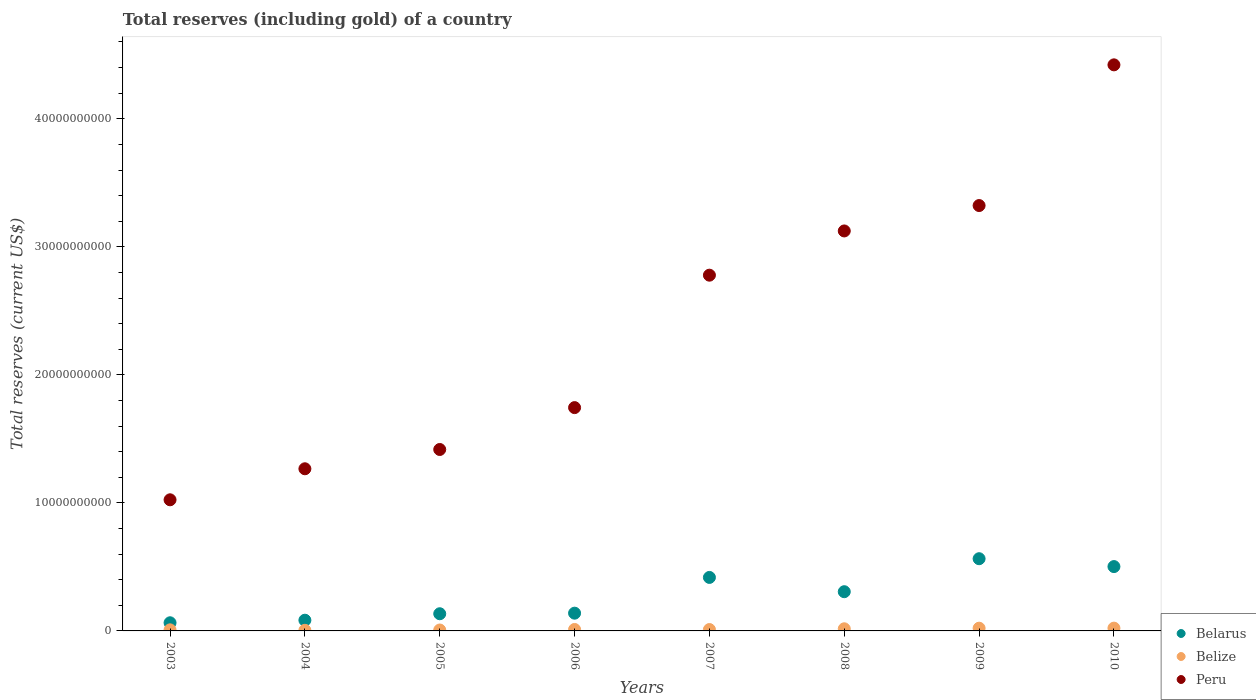Is the number of dotlines equal to the number of legend labels?
Make the answer very short. Yes. What is the total reserves (including gold) in Belarus in 2009?
Keep it short and to the point. 5.64e+09. Across all years, what is the maximum total reserves (including gold) in Belarus?
Give a very brief answer. 5.64e+09. Across all years, what is the minimum total reserves (including gold) in Belize?
Your answer should be very brief. 4.83e+07. In which year was the total reserves (including gold) in Belarus maximum?
Provide a succinct answer. 2009. What is the total total reserves (including gold) in Peru in the graph?
Offer a very short reply. 1.91e+11. What is the difference between the total reserves (including gold) in Peru in 2007 and that in 2009?
Your answer should be very brief. -5.44e+09. What is the difference between the total reserves (including gold) in Belarus in 2004 and the total reserves (including gold) in Peru in 2009?
Your answer should be compact. -3.24e+1. What is the average total reserves (including gold) in Belize per year?
Ensure brevity in your answer.  1.28e+08. In the year 2010, what is the difference between the total reserves (including gold) in Belize and total reserves (including gold) in Belarus?
Provide a short and direct response. -4.81e+09. In how many years, is the total reserves (including gold) in Peru greater than 8000000000 US$?
Your answer should be very brief. 8. What is the ratio of the total reserves (including gold) in Belarus in 2008 to that in 2009?
Your answer should be compact. 0.54. Is the difference between the total reserves (including gold) in Belize in 2005 and 2010 greater than the difference between the total reserves (including gold) in Belarus in 2005 and 2010?
Offer a terse response. Yes. What is the difference between the highest and the second highest total reserves (including gold) in Belarus?
Your answer should be compact. 6.15e+08. What is the difference between the highest and the lowest total reserves (including gold) in Belarus?
Provide a succinct answer. 5.00e+09. In how many years, is the total reserves (including gold) in Peru greater than the average total reserves (including gold) in Peru taken over all years?
Make the answer very short. 4. Is the total reserves (including gold) in Peru strictly greater than the total reserves (including gold) in Belarus over the years?
Offer a terse response. Yes. Is the total reserves (including gold) in Belize strictly less than the total reserves (including gold) in Peru over the years?
Your response must be concise. Yes. How many dotlines are there?
Give a very brief answer. 3. What is the difference between two consecutive major ticks on the Y-axis?
Offer a very short reply. 1.00e+1. Are the values on the major ticks of Y-axis written in scientific E-notation?
Provide a succinct answer. No. Does the graph contain grids?
Offer a very short reply. No. How many legend labels are there?
Provide a short and direct response. 3. What is the title of the graph?
Offer a terse response. Total reserves (including gold) of a country. Does "United States" appear as one of the legend labels in the graph?
Offer a terse response. No. What is the label or title of the Y-axis?
Your answer should be very brief. Total reserves (current US$). What is the Total reserves (current US$) of Belarus in 2003?
Ensure brevity in your answer.  6.37e+08. What is the Total reserves (current US$) of Belize in 2003?
Your answer should be very brief. 8.47e+07. What is the Total reserves (current US$) of Peru in 2003?
Your answer should be very brief. 1.02e+1. What is the Total reserves (current US$) of Belarus in 2004?
Your response must be concise. 8.37e+08. What is the Total reserves (current US$) in Belize in 2004?
Your answer should be compact. 4.83e+07. What is the Total reserves (current US$) in Peru in 2004?
Your answer should be compact. 1.27e+1. What is the Total reserves (current US$) in Belarus in 2005?
Your answer should be compact. 1.34e+09. What is the Total reserves (current US$) in Belize in 2005?
Provide a short and direct response. 7.14e+07. What is the Total reserves (current US$) of Peru in 2005?
Provide a short and direct response. 1.42e+1. What is the Total reserves (current US$) in Belarus in 2006?
Your response must be concise. 1.39e+09. What is the Total reserves (current US$) in Belize in 2006?
Offer a terse response. 1.14e+08. What is the Total reserves (current US$) in Peru in 2006?
Provide a succinct answer. 1.74e+1. What is the Total reserves (current US$) of Belarus in 2007?
Your answer should be very brief. 4.18e+09. What is the Total reserves (current US$) in Belize in 2007?
Provide a short and direct response. 1.09e+08. What is the Total reserves (current US$) in Peru in 2007?
Your answer should be very brief. 2.78e+1. What is the Total reserves (current US$) in Belarus in 2008?
Give a very brief answer. 3.06e+09. What is the Total reserves (current US$) in Belize in 2008?
Your answer should be compact. 1.66e+08. What is the Total reserves (current US$) of Peru in 2008?
Keep it short and to the point. 3.12e+1. What is the Total reserves (current US$) of Belarus in 2009?
Your response must be concise. 5.64e+09. What is the Total reserves (current US$) of Belize in 2009?
Offer a very short reply. 2.14e+08. What is the Total reserves (current US$) of Peru in 2009?
Offer a very short reply. 3.32e+1. What is the Total reserves (current US$) of Belarus in 2010?
Ensure brevity in your answer.  5.03e+09. What is the Total reserves (current US$) of Belize in 2010?
Give a very brief answer. 2.18e+08. What is the Total reserves (current US$) of Peru in 2010?
Your response must be concise. 4.42e+1. Across all years, what is the maximum Total reserves (current US$) of Belarus?
Offer a very short reply. 5.64e+09. Across all years, what is the maximum Total reserves (current US$) of Belize?
Your answer should be very brief. 2.18e+08. Across all years, what is the maximum Total reserves (current US$) of Peru?
Keep it short and to the point. 4.42e+1. Across all years, what is the minimum Total reserves (current US$) in Belarus?
Keep it short and to the point. 6.37e+08. Across all years, what is the minimum Total reserves (current US$) of Belize?
Provide a succinct answer. 4.83e+07. Across all years, what is the minimum Total reserves (current US$) of Peru?
Provide a short and direct response. 1.02e+1. What is the total Total reserves (current US$) in Belarus in the graph?
Your answer should be very brief. 2.21e+1. What is the total Total reserves (current US$) of Belize in the graph?
Your answer should be very brief. 1.02e+09. What is the total Total reserves (current US$) of Peru in the graph?
Provide a succinct answer. 1.91e+11. What is the difference between the Total reserves (current US$) in Belarus in 2003 and that in 2004?
Give a very brief answer. -2.00e+08. What is the difference between the Total reserves (current US$) of Belize in 2003 and that in 2004?
Your answer should be compact. 3.64e+07. What is the difference between the Total reserves (current US$) of Peru in 2003 and that in 2004?
Keep it short and to the point. -2.42e+09. What is the difference between the Total reserves (current US$) in Belarus in 2003 and that in 2005?
Keep it short and to the point. -7.05e+08. What is the difference between the Total reserves (current US$) in Belize in 2003 and that in 2005?
Offer a very short reply. 1.33e+07. What is the difference between the Total reserves (current US$) in Peru in 2003 and that in 2005?
Your response must be concise. -3.93e+09. What is the difference between the Total reserves (current US$) in Belarus in 2003 and that in 2006?
Offer a terse response. -7.50e+08. What is the difference between the Total reserves (current US$) in Belize in 2003 and that in 2006?
Offer a terse response. -2.90e+07. What is the difference between the Total reserves (current US$) of Peru in 2003 and that in 2006?
Your answer should be compact. -7.20e+09. What is the difference between the Total reserves (current US$) in Belarus in 2003 and that in 2007?
Provide a succinct answer. -3.54e+09. What is the difference between the Total reserves (current US$) of Belize in 2003 and that in 2007?
Your answer should be compact. -2.38e+07. What is the difference between the Total reserves (current US$) in Peru in 2003 and that in 2007?
Provide a succinct answer. -1.75e+1. What is the difference between the Total reserves (current US$) of Belarus in 2003 and that in 2008?
Your response must be concise. -2.43e+09. What is the difference between the Total reserves (current US$) of Belize in 2003 and that in 2008?
Give a very brief answer. -8.15e+07. What is the difference between the Total reserves (current US$) in Peru in 2003 and that in 2008?
Provide a short and direct response. -2.10e+1. What is the difference between the Total reserves (current US$) of Belarus in 2003 and that in 2009?
Provide a succinct answer. -5.00e+09. What is the difference between the Total reserves (current US$) of Belize in 2003 and that in 2009?
Your answer should be compact. -1.29e+08. What is the difference between the Total reserves (current US$) in Peru in 2003 and that in 2009?
Your response must be concise. -2.30e+1. What is the difference between the Total reserves (current US$) in Belarus in 2003 and that in 2010?
Offer a terse response. -4.39e+09. What is the difference between the Total reserves (current US$) in Belize in 2003 and that in 2010?
Make the answer very short. -1.33e+08. What is the difference between the Total reserves (current US$) of Peru in 2003 and that in 2010?
Provide a succinct answer. -3.40e+1. What is the difference between the Total reserves (current US$) of Belarus in 2004 and that in 2005?
Offer a terse response. -5.05e+08. What is the difference between the Total reserves (current US$) in Belize in 2004 and that in 2005?
Keep it short and to the point. -2.31e+07. What is the difference between the Total reserves (current US$) in Peru in 2004 and that in 2005?
Give a very brief answer. -1.51e+09. What is the difference between the Total reserves (current US$) of Belarus in 2004 and that in 2006?
Provide a succinct answer. -5.49e+08. What is the difference between the Total reserves (current US$) in Belize in 2004 and that in 2006?
Your response must be concise. -6.55e+07. What is the difference between the Total reserves (current US$) of Peru in 2004 and that in 2006?
Your response must be concise. -4.78e+09. What is the difference between the Total reserves (current US$) of Belarus in 2004 and that in 2007?
Ensure brevity in your answer.  -3.34e+09. What is the difference between the Total reserves (current US$) of Belize in 2004 and that in 2007?
Provide a short and direct response. -6.03e+07. What is the difference between the Total reserves (current US$) in Peru in 2004 and that in 2007?
Your answer should be compact. -1.51e+1. What is the difference between the Total reserves (current US$) in Belarus in 2004 and that in 2008?
Offer a very short reply. -2.23e+09. What is the difference between the Total reserves (current US$) of Belize in 2004 and that in 2008?
Provide a succinct answer. -1.18e+08. What is the difference between the Total reserves (current US$) of Peru in 2004 and that in 2008?
Your response must be concise. -1.86e+1. What is the difference between the Total reserves (current US$) of Belarus in 2004 and that in 2009?
Provide a short and direct response. -4.80e+09. What is the difference between the Total reserves (current US$) in Belize in 2004 and that in 2009?
Provide a succinct answer. -1.65e+08. What is the difference between the Total reserves (current US$) of Peru in 2004 and that in 2009?
Provide a short and direct response. -2.06e+1. What is the difference between the Total reserves (current US$) in Belarus in 2004 and that in 2010?
Offer a very short reply. -4.19e+09. What is the difference between the Total reserves (current US$) in Belize in 2004 and that in 2010?
Ensure brevity in your answer.  -1.70e+08. What is the difference between the Total reserves (current US$) of Peru in 2004 and that in 2010?
Make the answer very short. -3.16e+1. What is the difference between the Total reserves (current US$) in Belarus in 2005 and that in 2006?
Keep it short and to the point. -4.46e+07. What is the difference between the Total reserves (current US$) of Belize in 2005 and that in 2006?
Your answer should be compact. -4.24e+07. What is the difference between the Total reserves (current US$) in Peru in 2005 and that in 2006?
Keep it short and to the point. -3.27e+09. What is the difference between the Total reserves (current US$) in Belarus in 2005 and that in 2007?
Your answer should be very brief. -2.84e+09. What is the difference between the Total reserves (current US$) of Belize in 2005 and that in 2007?
Your answer should be compact. -3.72e+07. What is the difference between the Total reserves (current US$) in Peru in 2005 and that in 2007?
Provide a succinct answer. -1.36e+1. What is the difference between the Total reserves (current US$) of Belarus in 2005 and that in 2008?
Give a very brief answer. -1.72e+09. What is the difference between the Total reserves (current US$) of Belize in 2005 and that in 2008?
Your answer should be very brief. -9.48e+07. What is the difference between the Total reserves (current US$) in Peru in 2005 and that in 2008?
Ensure brevity in your answer.  -1.71e+1. What is the difference between the Total reserves (current US$) in Belarus in 2005 and that in 2009?
Provide a succinct answer. -4.30e+09. What is the difference between the Total reserves (current US$) in Belize in 2005 and that in 2009?
Make the answer very short. -1.42e+08. What is the difference between the Total reserves (current US$) in Peru in 2005 and that in 2009?
Ensure brevity in your answer.  -1.91e+1. What is the difference between the Total reserves (current US$) in Belarus in 2005 and that in 2010?
Provide a short and direct response. -3.68e+09. What is the difference between the Total reserves (current US$) in Belize in 2005 and that in 2010?
Your answer should be compact. -1.47e+08. What is the difference between the Total reserves (current US$) of Peru in 2005 and that in 2010?
Your response must be concise. -3.00e+1. What is the difference between the Total reserves (current US$) of Belarus in 2006 and that in 2007?
Make the answer very short. -2.79e+09. What is the difference between the Total reserves (current US$) of Belize in 2006 and that in 2007?
Ensure brevity in your answer.  5.21e+06. What is the difference between the Total reserves (current US$) in Peru in 2006 and that in 2007?
Give a very brief answer. -1.03e+1. What is the difference between the Total reserves (current US$) in Belarus in 2006 and that in 2008?
Offer a terse response. -1.68e+09. What is the difference between the Total reserves (current US$) of Belize in 2006 and that in 2008?
Ensure brevity in your answer.  -5.24e+07. What is the difference between the Total reserves (current US$) of Peru in 2006 and that in 2008?
Keep it short and to the point. -1.38e+1. What is the difference between the Total reserves (current US$) in Belarus in 2006 and that in 2009?
Provide a short and direct response. -4.25e+09. What is the difference between the Total reserves (current US$) in Belize in 2006 and that in 2009?
Ensure brevity in your answer.  -1.00e+08. What is the difference between the Total reserves (current US$) of Peru in 2006 and that in 2009?
Provide a succinct answer. -1.58e+1. What is the difference between the Total reserves (current US$) in Belarus in 2006 and that in 2010?
Your answer should be compact. -3.64e+09. What is the difference between the Total reserves (current US$) in Belize in 2006 and that in 2010?
Ensure brevity in your answer.  -1.04e+08. What is the difference between the Total reserves (current US$) in Peru in 2006 and that in 2010?
Provide a short and direct response. -2.68e+1. What is the difference between the Total reserves (current US$) in Belarus in 2007 and that in 2008?
Offer a very short reply. 1.12e+09. What is the difference between the Total reserves (current US$) of Belize in 2007 and that in 2008?
Your response must be concise. -5.77e+07. What is the difference between the Total reserves (current US$) of Peru in 2007 and that in 2008?
Your answer should be compact. -3.46e+09. What is the difference between the Total reserves (current US$) in Belarus in 2007 and that in 2009?
Give a very brief answer. -1.46e+09. What is the difference between the Total reserves (current US$) of Belize in 2007 and that in 2009?
Give a very brief answer. -1.05e+08. What is the difference between the Total reserves (current US$) of Peru in 2007 and that in 2009?
Provide a succinct answer. -5.44e+09. What is the difference between the Total reserves (current US$) in Belarus in 2007 and that in 2010?
Make the answer very short. -8.47e+08. What is the difference between the Total reserves (current US$) of Belize in 2007 and that in 2010?
Ensure brevity in your answer.  -1.09e+08. What is the difference between the Total reserves (current US$) in Peru in 2007 and that in 2010?
Provide a short and direct response. -1.64e+1. What is the difference between the Total reserves (current US$) in Belarus in 2008 and that in 2009?
Give a very brief answer. -2.58e+09. What is the difference between the Total reserves (current US$) of Belize in 2008 and that in 2009?
Give a very brief answer. -4.75e+07. What is the difference between the Total reserves (current US$) of Peru in 2008 and that in 2009?
Give a very brief answer. -1.98e+09. What is the difference between the Total reserves (current US$) in Belarus in 2008 and that in 2010?
Offer a terse response. -1.96e+09. What is the difference between the Total reserves (current US$) in Belize in 2008 and that in 2010?
Ensure brevity in your answer.  -5.18e+07. What is the difference between the Total reserves (current US$) of Peru in 2008 and that in 2010?
Give a very brief answer. -1.30e+1. What is the difference between the Total reserves (current US$) in Belarus in 2009 and that in 2010?
Your answer should be very brief. 6.15e+08. What is the difference between the Total reserves (current US$) of Belize in 2009 and that in 2010?
Offer a very short reply. -4.32e+06. What is the difference between the Total reserves (current US$) of Peru in 2009 and that in 2010?
Offer a very short reply. -1.10e+1. What is the difference between the Total reserves (current US$) of Belarus in 2003 and the Total reserves (current US$) of Belize in 2004?
Provide a succinct answer. 5.88e+08. What is the difference between the Total reserves (current US$) of Belarus in 2003 and the Total reserves (current US$) of Peru in 2004?
Provide a succinct answer. -1.20e+1. What is the difference between the Total reserves (current US$) of Belize in 2003 and the Total reserves (current US$) of Peru in 2004?
Give a very brief answer. -1.26e+1. What is the difference between the Total reserves (current US$) in Belarus in 2003 and the Total reserves (current US$) in Belize in 2005?
Keep it short and to the point. 5.65e+08. What is the difference between the Total reserves (current US$) in Belarus in 2003 and the Total reserves (current US$) in Peru in 2005?
Your answer should be compact. -1.35e+1. What is the difference between the Total reserves (current US$) in Belize in 2003 and the Total reserves (current US$) in Peru in 2005?
Provide a succinct answer. -1.41e+1. What is the difference between the Total reserves (current US$) in Belarus in 2003 and the Total reserves (current US$) in Belize in 2006?
Make the answer very short. 5.23e+08. What is the difference between the Total reserves (current US$) of Belarus in 2003 and the Total reserves (current US$) of Peru in 2006?
Ensure brevity in your answer.  -1.68e+1. What is the difference between the Total reserves (current US$) in Belize in 2003 and the Total reserves (current US$) in Peru in 2006?
Your answer should be very brief. -1.74e+1. What is the difference between the Total reserves (current US$) of Belarus in 2003 and the Total reserves (current US$) of Belize in 2007?
Make the answer very short. 5.28e+08. What is the difference between the Total reserves (current US$) of Belarus in 2003 and the Total reserves (current US$) of Peru in 2007?
Your answer should be compact. -2.71e+1. What is the difference between the Total reserves (current US$) in Belize in 2003 and the Total reserves (current US$) in Peru in 2007?
Provide a short and direct response. -2.77e+1. What is the difference between the Total reserves (current US$) of Belarus in 2003 and the Total reserves (current US$) of Belize in 2008?
Your answer should be very brief. 4.70e+08. What is the difference between the Total reserves (current US$) in Belarus in 2003 and the Total reserves (current US$) in Peru in 2008?
Ensure brevity in your answer.  -3.06e+1. What is the difference between the Total reserves (current US$) of Belize in 2003 and the Total reserves (current US$) of Peru in 2008?
Your answer should be very brief. -3.12e+1. What is the difference between the Total reserves (current US$) in Belarus in 2003 and the Total reserves (current US$) in Belize in 2009?
Ensure brevity in your answer.  4.23e+08. What is the difference between the Total reserves (current US$) in Belarus in 2003 and the Total reserves (current US$) in Peru in 2009?
Keep it short and to the point. -3.26e+1. What is the difference between the Total reserves (current US$) of Belize in 2003 and the Total reserves (current US$) of Peru in 2009?
Provide a succinct answer. -3.31e+1. What is the difference between the Total reserves (current US$) in Belarus in 2003 and the Total reserves (current US$) in Belize in 2010?
Provide a succinct answer. 4.19e+08. What is the difference between the Total reserves (current US$) of Belarus in 2003 and the Total reserves (current US$) of Peru in 2010?
Your answer should be very brief. -4.36e+1. What is the difference between the Total reserves (current US$) in Belize in 2003 and the Total reserves (current US$) in Peru in 2010?
Give a very brief answer. -4.41e+1. What is the difference between the Total reserves (current US$) of Belarus in 2004 and the Total reserves (current US$) of Belize in 2005?
Provide a short and direct response. 7.66e+08. What is the difference between the Total reserves (current US$) of Belarus in 2004 and the Total reserves (current US$) of Peru in 2005?
Your response must be concise. -1.33e+1. What is the difference between the Total reserves (current US$) of Belize in 2004 and the Total reserves (current US$) of Peru in 2005?
Keep it short and to the point. -1.41e+1. What is the difference between the Total reserves (current US$) of Belarus in 2004 and the Total reserves (current US$) of Belize in 2006?
Offer a very short reply. 7.23e+08. What is the difference between the Total reserves (current US$) in Belarus in 2004 and the Total reserves (current US$) in Peru in 2006?
Ensure brevity in your answer.  -1.66e+1. What is the difference between the Total reserves (current US$) of Belize in 2004 and the Total reserves (current US$) of Peru in 2006?
Offer a terse response. -1.74e+1. What is the difference between the Total reserves (current US$) in Belarus in 2004 and the Total reserves (current US$) in Belize in 2007?
Offer a terse response. 7.28e+08. What is the difference between the Total reserves (current US$) of Belarus in 2004 and the Total reserves (current US$) of Peru in 2007?
Give a very brief answer. -2.69e+1. What is the difference between the Total reserves (current US$) in Belize in 2004 and the Total reserves (current US$) in Peru in 2007?
Make the answer very short. -2.77e+1. What is the difference between the Total reserves (current US$) in Belarus in 2004 and the Total reserves (current US$) in Belize in 2008?
Offer a very short reply. 6.71e+08. What is the difference between the Total reserves (current US$) of Belarus in 2004 and the Total reserves (current US$) of Peru in 2008?
Make the answer very short. -3.04e+1. What is the difference between the Total reserves (current US$) in Belize in 2004 and the Total reserves (current US$) in Peru in 2008?
Offer a terse response. -3.12e+1. What is the difference between the Total reserves (current US$) of Belarus in 2004 and the Total reserves (current US$) of Belize in 2009?
Your answer should be compact. 6.23e+08. What is the difference between the Total reserves (current US$) of Belarus in 2004 and the Total reserves (current US$) of Peru in 2009?
Provide a succinct answer. -3.24e+1. What is the difference between the Total reserves (current US$) in Belize in 2004 and the Total reserves (current US$) in Peru in 2009?
Give a very brief answer. -3.32e+1. What is the difference between the Total reserves (current US$) of Belarus in 2004 and the Total reserves (current US$) of Belize in 2010?
Ensure brevity in your answer.  6.19e+08. What is the difference between the Total reserves (current US$) in Belarus in 2004 and the Total reserves (current US$) in Peru in 2010?
Offer a terse response. -4.34e+1. What is the difference between the Total reserves (current US$) in Belize in 2004 and the Total reserves (current US$) in Peru in 2010?
Provide a short and direct response. -4.42e+1. What is the difference between the Total reserves (current US$) of Belarus in 2005 and the Total reserves (current US$) of Belize in 2006?
Your response must be concise. 1.23e+09. What is the difference between the Total reserves (current US$) of Belarus in 2005 and the Total reserves (current US$) of Peru in 2006?
Provide a short and direct response. -1.61e+1. What is the difference between the Total reserves (current US$) in Belize in 2005 and the Total reserves (current US$) in Peru in 2006?
Your answer should be compact. -1.74e+1. What is the difference between the Total reserves (current US$) in Belarus in 2005 and the Total reserves (current US$) in Belize in 2007?
Your answer should be very brief. 1.23e+09. What is the difference between the Total reserves (current US$) of Belarus in 2005 and the Total reserves (current US$) of Peru in 2007?
Keep it short and to the point. -2.64e+1. What is the difference between the Total reserves (current US$) of Belize in 2005 and the Total reserves (current US$) of Peru in 2007?
Offer a terse response. -2.77e+1. What is the difference between the Total reserves (current US$) of Belarus in 2005 and the Total reserves (current US$) of Belize in 2008?
Ensure brevity in your answer.  1.18e+09. What is the difference between the Total reserves (current US$) of Belarus in 2005 and the Total reserves (current US$) of Peru in 2008?
Offer a very short reply. -2.99e+1. What is the difference between the Total reserves (current US$) in Belize in 2005 and the Total reserves (current US$) in Peru in 2008?
Make the answer very short. -3.12e+1. What is the difference between the Total reserves (current US$) of Belarus in 2005 and the Total reserves (current US$) of Belize in 2009?
Provide a short and direct response. 1.13e+09. What is the difference between the Total reserves (current US$) in Belarus in 2005 and the Total reserves (current US$) in Peru in 2009?
Your answer should be very brief. -3.19e+1. What is the difference between the Total reserves (current US$) of Belize in 2005 and the Total reserves (current US$) of Peru in 2009?
Your answer should be compact. -3.32e+1. What is the difference between the Total reserves (current US$) in Belarus in 2005 and the Total reserves (current US$) in Belize in 2010?
Your answer should be very brief. 1.12e+09. What is the difference between the Total reserves (current US$) in Belarus in 2005 and the Total reserves (current US$) in Peru in 2010?
Provide a short and direct response. -4.29e+1. What is the difference between the Total reserves (current US$) in Belize in 2005 and the Total reserves (current US$) in Peru in 2010?
Offer a very short reply. -4.41e+1. What is the difference between the Total reserves (current US$) in Belarus in 2006 and the Total reserves (current US$) in Belize in 2007?
Your response must be concise. 1.28e+09. What is the difference between the Total reserves (current US$) in Belarus in 2006 and the Total reserves (current US$) in Peru in 2007?
Your answer should be very brief. -2.64e+1. What is the difference between the Total reserves (current US$) in Belize in 2006 and the Total reserves (current US$) in Peru in 2007?
Offer a very short reply. -2.77e+1. What is the difference between the Total reserves (current US$) of Belarus in 2006 and the Total reserves (current US$) of Belize in 2008?
Your answer should be compact. 1.22e+09. What is the difference between the Total reserves (current US$) of Belarus in 2006 and the Total reserves (current US$) of Peru in 2008?
Offer a terse response. -2.99e+1. What is the difference between the Total reserves (current US$) of Belize in 2006 and the Total reserves (current US$) of Peru in 2008?
Provide a succinct answer. -3.11e+1. What is the difference between the Total reserves (current US$) in Belarus in 2006 and the Total reserves (current US$) in Belize in 2009?
Give a very brief answer. 1.17e+09. What is the difference between the Total reserves (current US$) in Belarus in 2006 and the Total reserves (current US$) in Peru in 2009?
Offer a terse response. -3.18e+1. What is the difference between the Total reserves (current US$) of Belize in 2006 and the Total reserves (current US$) of Peru in 2009?
Ensure brevity in your answer.  -3.31e+1. What is the difference between the Total reserves (current US$) of Belarus in 2006 and the Total reserves (current US$) of Belize in 2010?
Give a very brief answer. 1.17e+09. What is the difference between the Total reserves (current US$) in Belarus in 2006 and the Total reserves (current US$) in Peru in 2010?
Ensure brevity in your answer.  -4.28e+1. What is the difference between the Total reserves (current US$) of Belize in 2006 and the Total reserves (current US$) of Peru in 2010?
Give a very brief answer. -4.41e+1. What is the difference between the Total reserves (current US$) of Belarus in 2007 and the Total reserves (current US$) of Belize in 2008?
Make the answer very short. 4.01e+09. What is the difference between the Total reserves (current US$) of Belarus in 2007 and the Total reserves (current US$) of Peru in 2008?
Provide a succinct answer. -2.71e+1. What is the difference between the Total reserves (current US$) in Belize in 2007 and the Total reserves (current US$) in Peru in 2008?
Your response must be concise. -3.11e+1. What is the difference between the Total reserves (current US$) in Belarus in 2007 and the Total reserves (current US$) in Belize in 2009?
Provide a short and direct response. 3.96e+09. What is the difference between the Total reserves (current US$) of Belarus in 2007 and the Total reserves (current US$) of Peru in 2009?
Offer a terse response. -2.90e+1. What is the difference between the Total reserves (current US$) of Belize in 2007 and the Total reserves (current US$) of Peru in 2009?
Make the answer very short. -3.31e+1. What is the difference between the Total reserves (current US$) of Belarus in 2007 and the Total reserves (current US$) of Belize in 2010?
Provide a succinct answer. 3.96e+09. What is the difference between the Total reserves (current US$) of Belarus in 2007 and the Total reserves (current US$) of Peru in 2010?
Provide a short and direct response. -4.00e+1. What is the difference between the Total reserves (current US$) of Belize in 2007 and the Total reserves (current US$) of Peru in 2010?
Offer a terse response. -4.41e+1. What is the difference between the Total reserves (current US$) of Belarus in 2008 and the Total reserves (current US$) of Belize in 2009?
Your response must be concise. 2.85e+09. What is the difference between the Total reserves (current US$) of Belarus in 2008 and the Total reserves (current US$) of Peru in 2009?
Ensure brevity in your answer.  -3.02e+1. What is the difference between the Total reserves (current US$) of Belize in 2008 and the Total reserves (current US$) of Peru in 2009?
Your answer should be compact. -3.31e+1. What is the difference between the Total reserves (current US$) in Belarus in 2008 and the Total reserves (current US$) in Belize in 2010?
Your response must be concise. 2.85e+09. What is the difference between the Total reserves (current US$) in Belarus in 2008 and the Total reserves (current US$) in Peru in 2010?
Make the answer very short. -4.12e+1. What is the difference between the Total reserves (current US$) in Belize in 2008 and the Total reserves (current US$) in Peru in 2010?
Your answer should be compact. -4.40e+1. What is the difference between the Total reserves (current US$) in Belarus in 2009 and the Total reserves (current US$) in Belize in 2010?
Your response must be concise. 5.42e+09. What is the difference between the Total reserves (current US$) of Belarus in 2009 and the Total reserves (current US$) of Peru in 2010?
Offer a very short reply. -3.86e+1. What is the difference between the Total reserves (current US$) of Belize in 2009 and the Total reserves (current US$) of Peru in 2010?
Make the answer very short. -4.40e+1. What is the average Total reserves (current US$) in Belarus per year?
Provide a succinct answer. 2.76e+09. What is the average Total reserves (current US$) of Belize per year?
Your response must be concise. 1.28e+08. What is the average Total reserves (current US$) of Peru per year?
Keep it short and to the point. 2.39e+1. In the year 2003, what is the difference between the Total reserves (current US$) of Belarus and Total reserves (current US$) of Belize?
Give a very brief answer. 5.52e+08. In the year 2003, what is the difference between the Total reserves (current US$) of Belarus and Total reserves (current US$) of Peru?
Provide a succinct answer. -9.61e+09. In the year 2003, what is the difference between the Total reserves (current US$) of Belize and Total reserves (current US$) of Peru?
Make the answer very short. -1.02e+1. In the year 2004, what is the difference between the Total reserves (current US$) of Belarus and Total reserves (current US$) of Belize?
Give a very brief answer. 7.89e+08. In the year 2004, what is the difference between the Total reserves (current US$) in Belarus and Total reserves (current US$) in Peru?
Keep it short and to the point. -1.18e+1. In the year 2004, what is the difference between the Total reserves (current US$) in Belize and Total reserves (current US$) in Peru?
Ensure brevity in your answer.  -1.26e+1. In the year 2005, what is the difference between the Total reserves (current US$) in Belarus and Total reserves (current US$) in Belize?
Your answer should be compact. 1.27e+09. In the year 2005, what is the difference between the Total reserves (current US$) in Belarus and Total reserves (current US$) in Peru?
Give a very brief answer. -1.28e+1. In the year 2005, what is the difference between the Total reserves (current US$) of Belize and Total reserves (current US$) of Peru?
Ensure brevity in your answer.  -1.41e+1. In the year 2006, what is the difference between the Total reserves (current US$) of Belarus and Total reserves (current US$) of Belize?
Provide a succinct answer. 1.27e+09. In the year 2006, what is the difference between the Total reserves (current US$) of Belarus and Total reserves (current US$) of Peru?
Make the answer very short. -1.61e+1. In the year 2006, what is the difference between the Total reserves (current US$) in Belize and Total reserves (current US$) in Peru?
Your answer should be very brief. -1.73e+1. In the year 2007, what is the difference between the Total reserves (current US$) of Belarus and Total reserves (current US$) of Belize?
Ensure brevity in your answer.  4.07e+09. In the year 2007, what is the difference between the Total reserves (current US$) in Belarus and Total reserves (current US$) in Peru?
Give a very brief answer. -2.36e+1. In the year 2007, what is the difference between the Total reserves (current US$) of Belize and Total reserves (current US$) of Peru?
Offer a very short reply. -2.77e+1. In the year 2008, what is the difference between the Total reserves (current US$) in Belarus and Total reserves (current US$) in Belize?
Offer a terse response. 2.90e+09. In the year 2008, what is the difference between the Total reserves (current US$) in Belarus and Total reserves (current US$) in Peru?
Ensure brevity in your answer.  -2.82e+1. In the year 2008, what is the difference between the Total reserves (current US$) in Belize and Total reserves (current US$) in Peru?
Ensure brevity in your answer.  -3.11e+1. In the year 2009, what is the difference between the Total reserves (current US$) of Belarus and Total reserves (current US$) of Belize?
Your answer should be compact. 5.43e+09. In the year 2009, what is the difference between the Total reserves (current US$) in Belarus and Total reserves (current US$) in Peru?
Provide a succinct answer. -2.76e+1. In the year 2009, what is the difference between the Total reserves (current US$) in Belize and Total reserves (current US$) in Peru?
Ensure brevity in your answer.  -3.30e+1. In the year 2010, what is the difference between the Total reserves (current US$) in Belarus and Total reserves (current US$) in Belize?
Keep it short and to the point. 4.81e+09. In the year 2010, what is the difference between the Total reserves (current US$) in Belarus and Total reserves (current US$) in Peru?
Provide a succinct answer. -3.92e+1. In the year 2010, what is the difference between the Total reserves (current US$) of Belize and Total reserves (current US$) of Peru?
Your response must be concise. -4.40e+1. What is the ratio of the Total reserves (current US$) in Belarus in 2003 to that in 2004?
Keep it short and to the point. 0.76. What is the ratio of the Total reserves (current US$) in Belize in 2003 to that in 2004?
Ensure brevity in your answer.  1.75. What is the ratio of the Total reserves (current US$) of Peru in 2003 to that in 2004?
Ensure brevity in your answer.  0.81. What is the ratio of the Total reserves (current US$) in Belarus in 2003 to that in 2005?
Your response must be concise. 0.47. What is the ratio of the Total reserves (current US$) in Belize in 2003 to that in 2005?
Offer a very short reply. 1.19. What is the ratio of the Total reserves (current US$) of Peru in 2003 to that in 2005?
Your answer should be compact. 0.72. What is the ratio of the Total reserves (current US$) in Belarus in 2003 to that in 2006?
Your answer should be compact. 0.46. What is the ratio of the Total reserves (current US$) of Belize in 2003 to that in 2006?
Your answer should be compact. 0.74. What is the ratio of the Total reserves (current US$) in Peru in 2003 to that in 2006?
Your answer should be very brief. 0.59. What is the ratio of the Total reserves (current US$) of Belarus in 2003 to that in 2007?
Provide a succinct answer. 0.15. What is the ratio of the Total reserves (current US$) in Belize in 2003 to that in 2007?
Give a very brief answer. 0.78. What is the ratio of the Total reserves (current US$) in Peru in 2003 to that in 2007?
Provide a succinct answer. 0.37. What is the ratio of the Total reserves (current US$) of Belarus in 2003 to that in 2008?
Your response must be concise. 0.21. What is the ratio of the Total reserves (current US$) in Belize in 2003 to that in 2008?
Offer a very short reply. 0.51. What is the ratio of the Total reserves (current US$) of Peru in 2003 to that in 2008?
Provide a succinct answer. 0.33. What is the ratio of the Total reserves (current US$) of Belarus in 2003 to that in 2009?
Provide a succinct answer. 0.11. What is the ratio of the Total reserves (current US$) in Belize in 2003 to that in 2009?
Make the answer very short. 0.4. What is the ratio of the Total reserves (current US$) in Peru in 2003 to that in 2009?
Provide a succinct answer. 0.31. What is the ratio of the Total reserves (current US$) of Belarus in 2003 to that in 2010?
Offer a terse response. 0.13. What is the ratio of the Total reserves (current US$) in Belize in 2003 to that in 2010?
Your answer should be compact. 0.39. What is the ratio of the Total reserves (current US$) of Peru in 2003 to that in 2010?
Provide a succinct answer. 0.23. What is the ratio of the Total reserves (current US$) in Belarus in 2004 to that in 2005?
Offer a very short reply. 0.62. What is the ratio of the Total reserves (current US$) of Belize in 2004 to that in 2005?
Give a very brief answer. 0.68. What is the ratio of the Total reserves (current US$) of Peru in 2004 to that in 2005?
Your answer should be compact. 0.89. What is the ratio of the Total reserves (current US$) of Belarus in 2004 to that in 2006?
Make the answer very short. 0.6. What is the ratio of the Total reserves (current US$) of Belize in 2004 to that in 2006?
Your answer should be compact. 0.42. What is the ratio of the Total reserves (current US$) in Peru in 2004 to that in 2006?
Your response must be concise. 0.73. What is the ratio of the Total reserves (current US$) in Belarus in 2004 to that in 2007?
Your answer should be very brief. 0.2. What is the ratio of the Total reserves (current US$) of Belize in 2004 to that in 2007?
Give a very brief answer. 0.44. What is the ratio of the Total reserves (current US$) in Peru in 2004 to that in 2007?
Keep it short and to the point. 0.46. What is the ratio of the Total reserves (current US$) in Belarus in 2004 to that in 2008?
Offer a terse response. 0.27. What is the ratio of the Total reserves (current US$) of Belize in 2004 to that in 2008?
Keep it short and to the point. 0.29. What is the ratio of the Total reserves (current US$) in Peru in 2004 to that in 2008?
Ensure brevity in your answer.  0.41. What is the ratio of the Total reserves (current US$) in Belarus in 2004 to that in 2009?
Your answer should be compact. 0.15. What is the ratio of the Total reserves (current US$) of Belize in 2004 to that in 2009?
Provide a succinct answer. 0.23. What is the ratio of the Total reserves (current US$) of Peru in 2004 to that in 2009?
Keep it short and to the point. 0.38. What is the ratio of the Total reserves (current US$) in Belarus in 2004 to that in 2010?
Your answer should be compact. 0.17. What is the ratio of the Total reserves (current US$) in Belize in 2004 to that in 2010?
Your answer should be very brief. 0.22. What is the ratio of the Total reserves (current US$) in Peru in 2004 to that in 2010?
Provide a succinct answer. 0.29. What is the ratio of the Total reserves (current US$) of Belarus in 2005 to that in 2006?
Ensure brevity in your answer.  0.97. What is the ratio of the Total reserves (current US$) in Belize in 2005 to that in 2006?
Make the answer very short. 0.63. What is the ratio of the Total reserves (current US$) in Peru in 2005 to that in 2006?
Your answer should be very brief. 0.81. What is the ratio of the Total reserves (current US$) of Belarus in 2005 to that in 2007?
Offer a very short reply. 0.32. What is the ratio of the Total reserves (current US$) of Belize in 2005 to that in 2007?
Keep it short and to the point. 0.66. What is the ratio of the Total reserves (current US$) in Peru in 2005 to that in 2007?
Your response must be concise. 0.51. What is the ratio of the Total reserves (current US$) of Belarus in 2005 to that in 2008?
Provide a short and direct response. 0.44. What is the ratio of the Total reserves (current US$) in Belize in 2005 to that in 2008?
Your answer should be compact. 0.43. What is the ratio of the Total reserves (current US$) in Peru in 2005 to that in 2008?
Offer a very short reply. 0.45. What is the ratio of the Total reserves (current US$) of Belarus in 2005 to that in 2009?
Your answer should be compact. 0.24. What is the ratio of the Total reserves (current US$) of Belize in 2005 to that in 2009?
Your answer should be very brief. 0.33. What is the ratio of the Total reserves (current US$) of Peru in 2005 to that in 2009?
Give a very brief answer. 0.43. What is the ratio of the Total reserves (current US$) in Belarus in 2005 to that in 2010?
Give a very brief answer. 0.27. What is the ratio of the Total reserves (current US$) of Belize in 2005 to that in 2010?
Offer a terse response. 0.33. What is the ratio of the Total reserves (current US$) of Peru in 2005 to that in 2010?
Ensure brevity in your answer.  0.32. What is the ratio of the Total reserves (current US$) in Belarus in 2006 to that in 2007?
Provide a short and direct response. 0.33. What is the ratio of the Total reserves (current US$) in Belize in 2006 to that in 2007?
Offer a terse response. 1.05. What is the ratio of the Total reserves (current US$) of Peru in 2006 to that in 2007?
Your answer should be compact. 0.63. What is the ratio of the Total reserves (current US$) of Belarus in 2006 to that in 2008?
Your answer should be compact. 0.45. What is the ratio of the Total reserves (current US$) in Belize in 2006 to that in 2008?
Ensure brevity in your answer.  0.68. What is the ratio of the Total reserves (current US$) of Peru in 2006 to that in 2008?
Provide a short and direct response. 0.56. What is the ratio of the Total reserves (current US$) of Belarus in 2006 to that in 2009?
Offer a very short reply. 0.25. What is the ratio of the Total reserves (current US$) of Belize in 2006 to that in 2009?
Your answer should be compact. 0.53. What is the ratio of the Total reserves (current US$) in Peru in 2006 to that in 2009?
Keep it short and to the point. 0.53. What is the ratio of the Total reserves (current US$) of Belarus in 2006 to that in 2010?
Your answer should be very brief. 0.28. What is the ratio of the Total reserves (current US$) in Belize in 2006 to that in 2010?
Your response must be concise. 0.52. What is the ratio of the Total reserves (current US$) in Peru in 2006 to that in 2010?
Offer a terse response. 0.39. What is the ratio of the Total reserves (current US$) of Belarus in 2007 to that in 2008?
Your answer should be very brief. 1.36. What is the ratio of the Total reserves (current US$) in Belize in 2007 to that in 2008?
Ensure brevity in your answer.  0.65. What is the ratio of the Total reserves (current US$) in Peru in 2007 to that in 2008?
Give a very brief answer. 0.89. What is the ratio of the Total reserves (current US$) in Belarus in 2007 to that in 2009?
Your answer should be very brief. 0.74. What is the ratio of the Total reserves (current US$) in Belize in 2007 to that in 2009?
Your answer should be compact. 0.51. What is the ratio of the Total reserves (current US$) in Peru in 2007 to that in 2009?
Offer a very short reply. 0.84. What is the ratio of the Total reserves (current US$) of Belarus in 2007 to that in 2010?
Provide a short and direct response. 0.83. What is the ratio of the Total reserves (current US$) of Belize in 2007 to that in 2010?
Keep it short and to the point. 0.5. What is the ratio of the Total reserves (current US$) in Peru in 2007 to that in 2010?
Provide a succinct answer. 0.63. What is the ratio of the Total reserves (current US$) in Belarus in 2008 to that in 2009?
Provide a succinct answer. 0.54. What is the ratio of the Total reserves (current US$) in Belize in 2008 to that in 2009?
Make the answer very short. 0.78. What is the ratio of the Total reserves (current US$) in Peru in 2008 to that in 2009?
Keep it short and to the point. 0.94. What is the ratio of the Total reserves (current US$) in Belarus in 2008 to that in 2010?
Ensure brevity in your answer.  0.61. What is the ratio of the Total reserves (current US$) of Belize in 2008 to that in 2010?
Offer a very short reply. 0.76. What is the ratio of the Total reserves (current US$) of Peru in 2008 to that in 2010?
Provide a short and direct response. 0.71. What is the ratio of the Total reserves (current US$) of Belarus in 2009 to that in 2010?
Provide a succinct answer. 1.12. What is the ratio of the Total reserves (current US$) in Belize in 2009 to that in 2010?
Your answer should be compact. 0.98. What is the ratio of the Total reserves (current US$) in Peru in 2009 to that in 2010?
Your answer should be compact. 0.75. What is the difference between the highest and the second highest Total reserves (current US$) in Belarus?
Your answer should be very brief. 6.15e+08. What is the difference between the highest and the second highest Total reserves (current US$) in Belize?
Your answer should be compact. 4.32e+06. What is the difference between the highest and the second highest Total reserves (current US$) of Peru?
Keep it short and to the point. 1.10e+1. What is the difference between the highest and the lowest Total reserves (current US$) of Belarus?
Give a very brief answer. 5.00e+09. What is the difference between the highest and the lowest Total reserves (current US$) of Belize?
Your response must be concise. 1.70e+08. What is the difference between the highest and the lowest Total reserves (current US$) in Peru?
Give a very brief answer. 3.40e+1. 